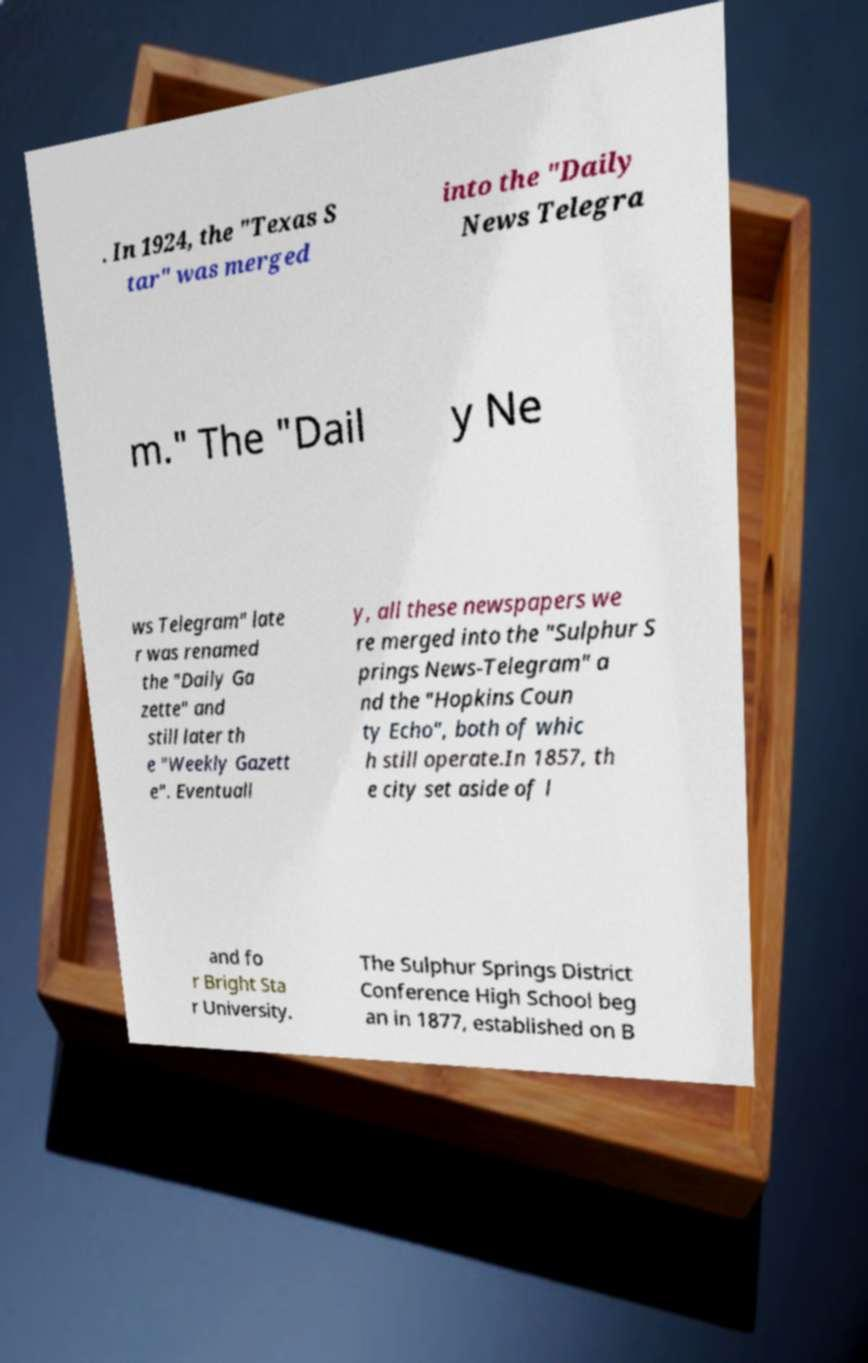For documentation purposes, I need the text within this image transcribed. Could you provide that? . In 1924, the "Texas S tar" was merged into the "Daily News Telegra m." The "Dail y Ne ws Telegram" late r was renamed the "Daily Ga zette" and still later th e "Weekly Gazett e". Eventuall y, all these newspapers we re merged into the "Sulphur S prings News-Telegram" a nd the "Hopkins Coun ty Echo", both of whic h still operate.In 1857, th e city set aside of l and fo r Bright Sta r University. The Sulphur Springs District Conference High School beg an in 1877, established on B 